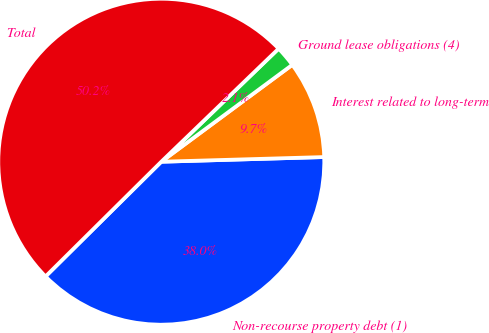Convert chart to OTSL. <chart><loc_0><loc_0><loc_500><loc_500><pie_chart><fcel>Non-recourse property debt (1)<fcel>Interest related to long-term<fcel>Ground lease obligations (4)<fcel>Total<nl><fcel>38.03%<fcel>9.68%<fcel>2.07%<fcel>50.23%<nl></chart> 